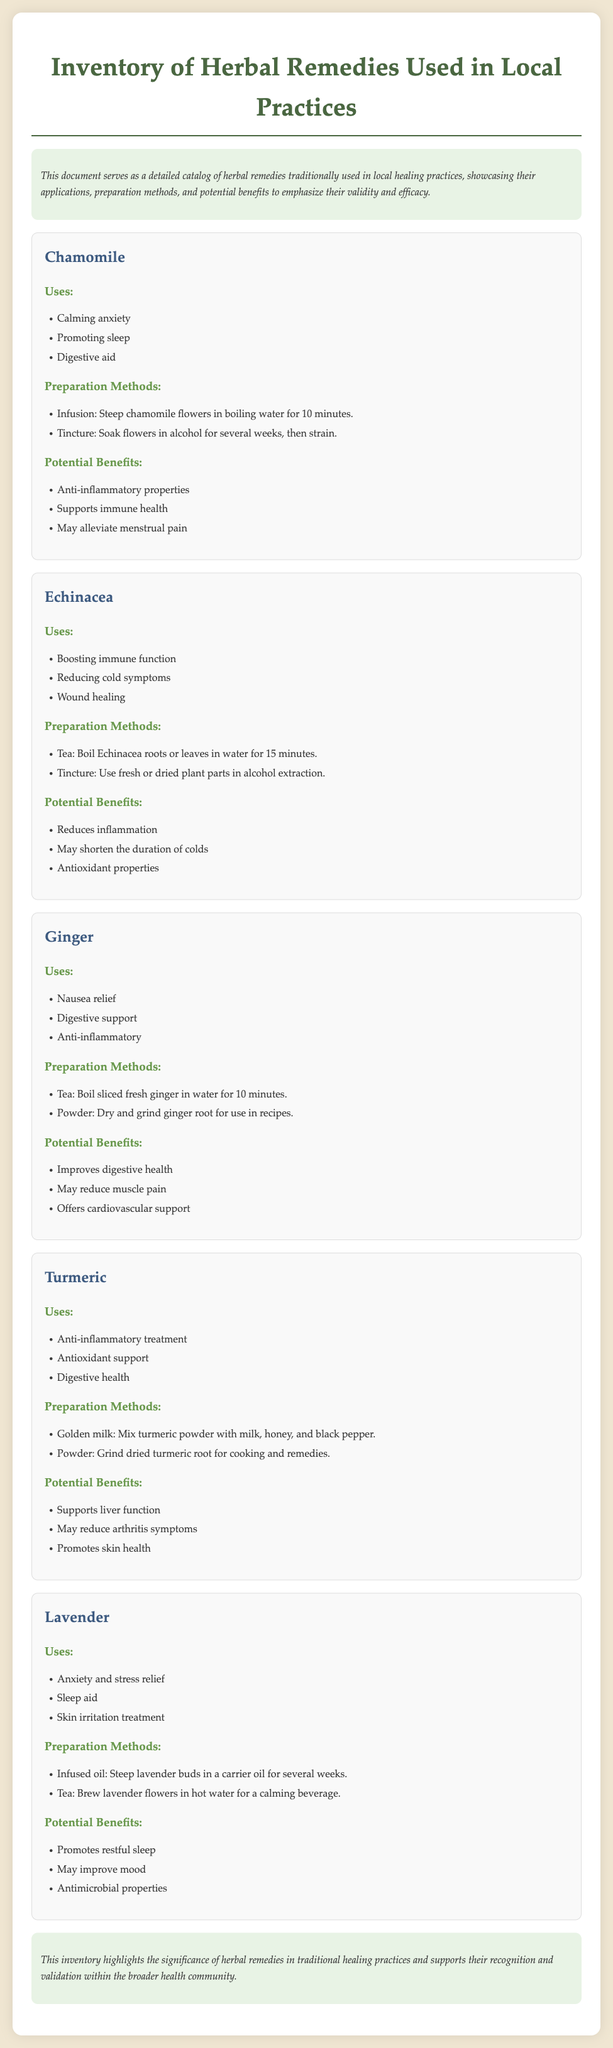What is the title of the document? The title is displayed prominently at the top of the document, stating the purpose of the content.
Answer: Inventory of Herbal Remedies Used in Local Practices How many herbs are listed in the document? The document provides details on five different herbs used in local practices.
Answer: 5 What is the first herb mentioned? The document outlines each herb starting with the one listed first in the catalog.
Answer: Chamomile Which preparation method is described for Ginger? The document specifies the preparation methods for each herb, including Ginger.
Answer: Boil sliced fresh ginger in water for 10 minutes What is one potential benefit of Echinacea? The document lists potential benefits under each herb, including one for Echinacea.
Answer: Reduces inflammation What type of oil is used for preparing Lavender? The document specifies the preparation method for Lavender, mentioning the type of oil.
Answer: Carrier oil List one use of Turmeric. The document presents uses for each herb, including Turmeric, in a specified section.
Answer: Anti-inflammatory treatment What is a common theme across the potential benefits of the herbs listed? The document frequently highlights similar health effects or supportive roles of the herbs, emphasizing their broader health impact.
Answer: Support immune health 